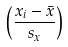Convert formula to latex. <formula><loc_0><loc_0><loc_500><loc_500>\left ( { \frac { x _ { i } - { \bar { x } } } { s _ { x } } } \right )</formula> 